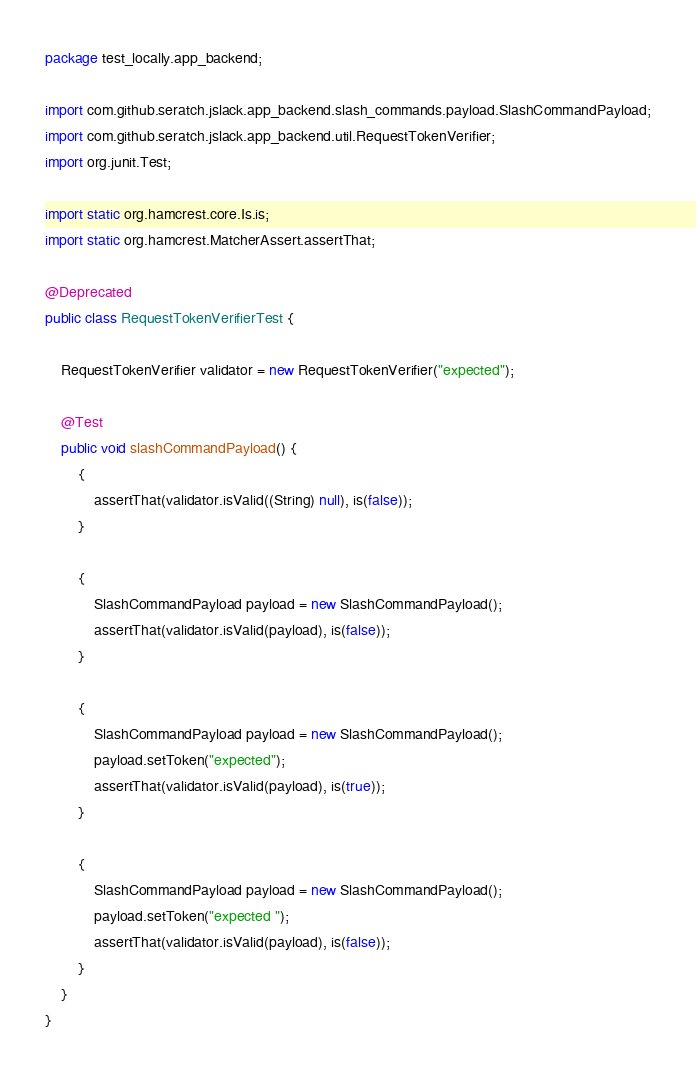<code> <loc_0><loc_0><loc_500><loc_500><_Java_>package test_locally.app_backend;

import com.github.seratch.jslack.app_backend.slash_commands.payload.SlashCommandPayload;
import com.github.seratch.jslack.app_backend.util.RequestTokenVerifier;
import org.junit.Test;

import static org.hamcrest.core.Is.is;
import static org.hamcrest.MatcherAssert.assertThat;

@Deprecated
public class RequestTokenVerifierTest {

    RequestTokenVerifier validator = new RequestTokenVerifier("expected");

    @Test
    public void slashCommandPayload() {
        {
            assertThat(validator.isValid((String) null), is(false));
        }

        {
            SlashCommandPayload payload = new SlashCommandPayload();
            assertThat(validator.isValid(payload), is(false));
        }

        {
            SlashCommandPayload payload = new SlashCommandPayload();
            payload.setToken("expected");
            assertThat(validator.isValid(payload), is(true));
        }

        {
            SlashCommandPayload payload = new SlashCommandPayload();
            payload.setToken("expected ");
            assertThat(validator.isValid(payload), is(false));
        }
    }
}
</code> 